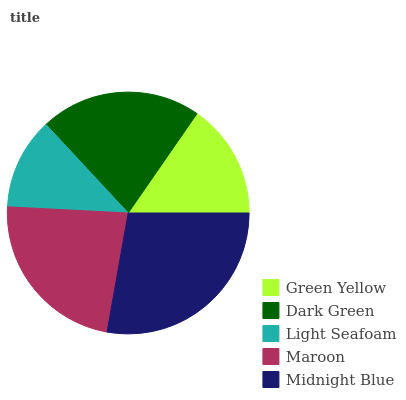Is Light Seafoam the minimum?
Answer yes or no. Yes. Is Midnight Blue the maximum?
Answer yes or no. Yes. Is Dark Green the minimum?
Answer yes or no. No. Is Dark Green the maximum?
Answer yes or no. No. Is Dark Green greater than Green Yellow?
Answer yes or no. Yes. Is Green Yellow less than Dark Green?
Answer yes or no. Yes. Is Green Yellow greater than Dark Green?
Answer yes or no. No. Is Dark Green less than Green Yellow?
Answer yes or no. No. Is Dark Green the high median?
Answer yes or no. Yes. Is Dark Green the low median?
Answer yes or no. Yes. Is Maroon the high median?
Answer yes or no. No. Is Midnight Blue the low median?
Answer yes or no. No. 